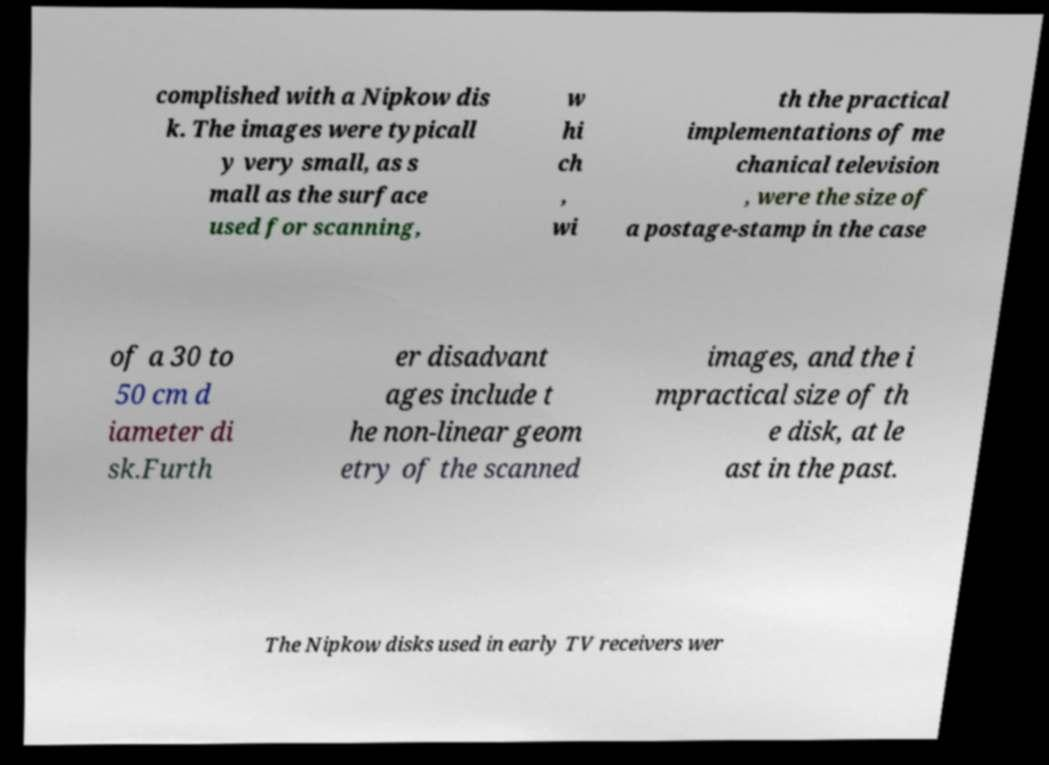Could you extract and type out the text from this image? complished with a Nipkow dis k. The images were typicall y very small, as s mall as the surface used for scanning, w hi ch , wi th the practical implementations of me chanical television , were the size of a postage-stamp in the case of a 30 to 50 cm d iameter di sk.Furth er disadvant ages include t he non-linear geom etry of the scanned images, and the i mpractical size of th e disk, at le ast in the past. The Nipkow disks used in early TV receivers wer 